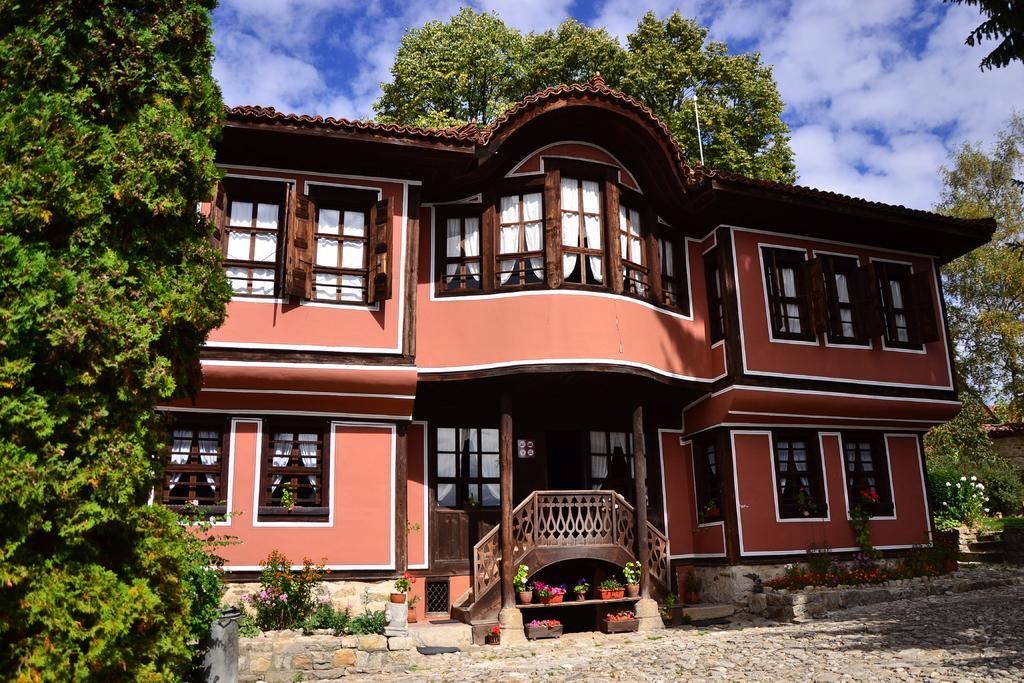Describe this image in one or two sentences. As we can see in the image there is a building, windows, curtains, plants, flowers, trees, sky and clouds. 